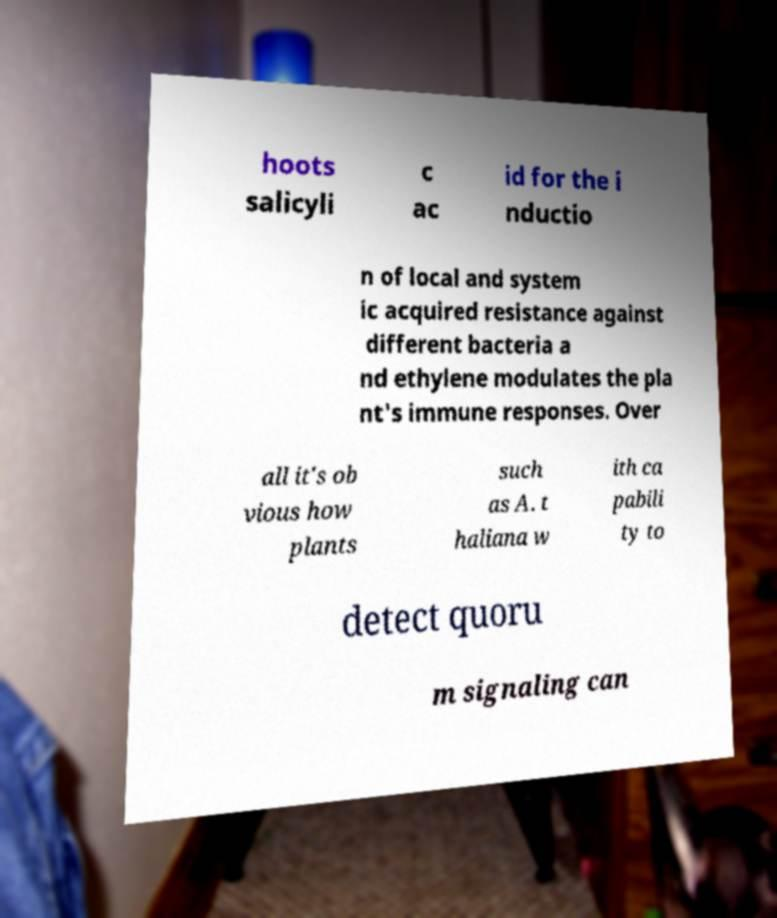Can you read and provide the text displayed in the image?This photo seems to have some interesting text. Can you extract and type it out for me? hoots salicyli c ac id for the i nductio n of local and system ic acquired resistance against different bacteria a nd ethylene modulates the pla nt's immune responses. Over all it's ob vious how plants such as A. t haliana w ith ca pabili ty to detect quoru m signaling can 